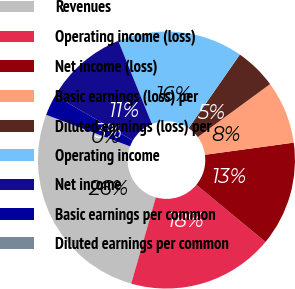Convert chart to OTSL. <chart><loc_0><loc_0><loc_500><loc_500><pie_chart><fcel>Revenues<fcel>Operating income (loss)<fcel>Net income (loss)<fcel>Basic earnings (loss) per<fcel>Diluted earnings (loss) per<fcel>Operating income<fcel>Net income<fcel>Basic earnings per common<fcel>Diluted earnings per common<nl><fcel>26.31%<fcel>18.42%<fcel>13.16%<fcel>7.9%<fcel>5.26%<fcel>15.79%<fcel>10.53%<fcel>2.63%<fcel>0.0%<nl></chart> 